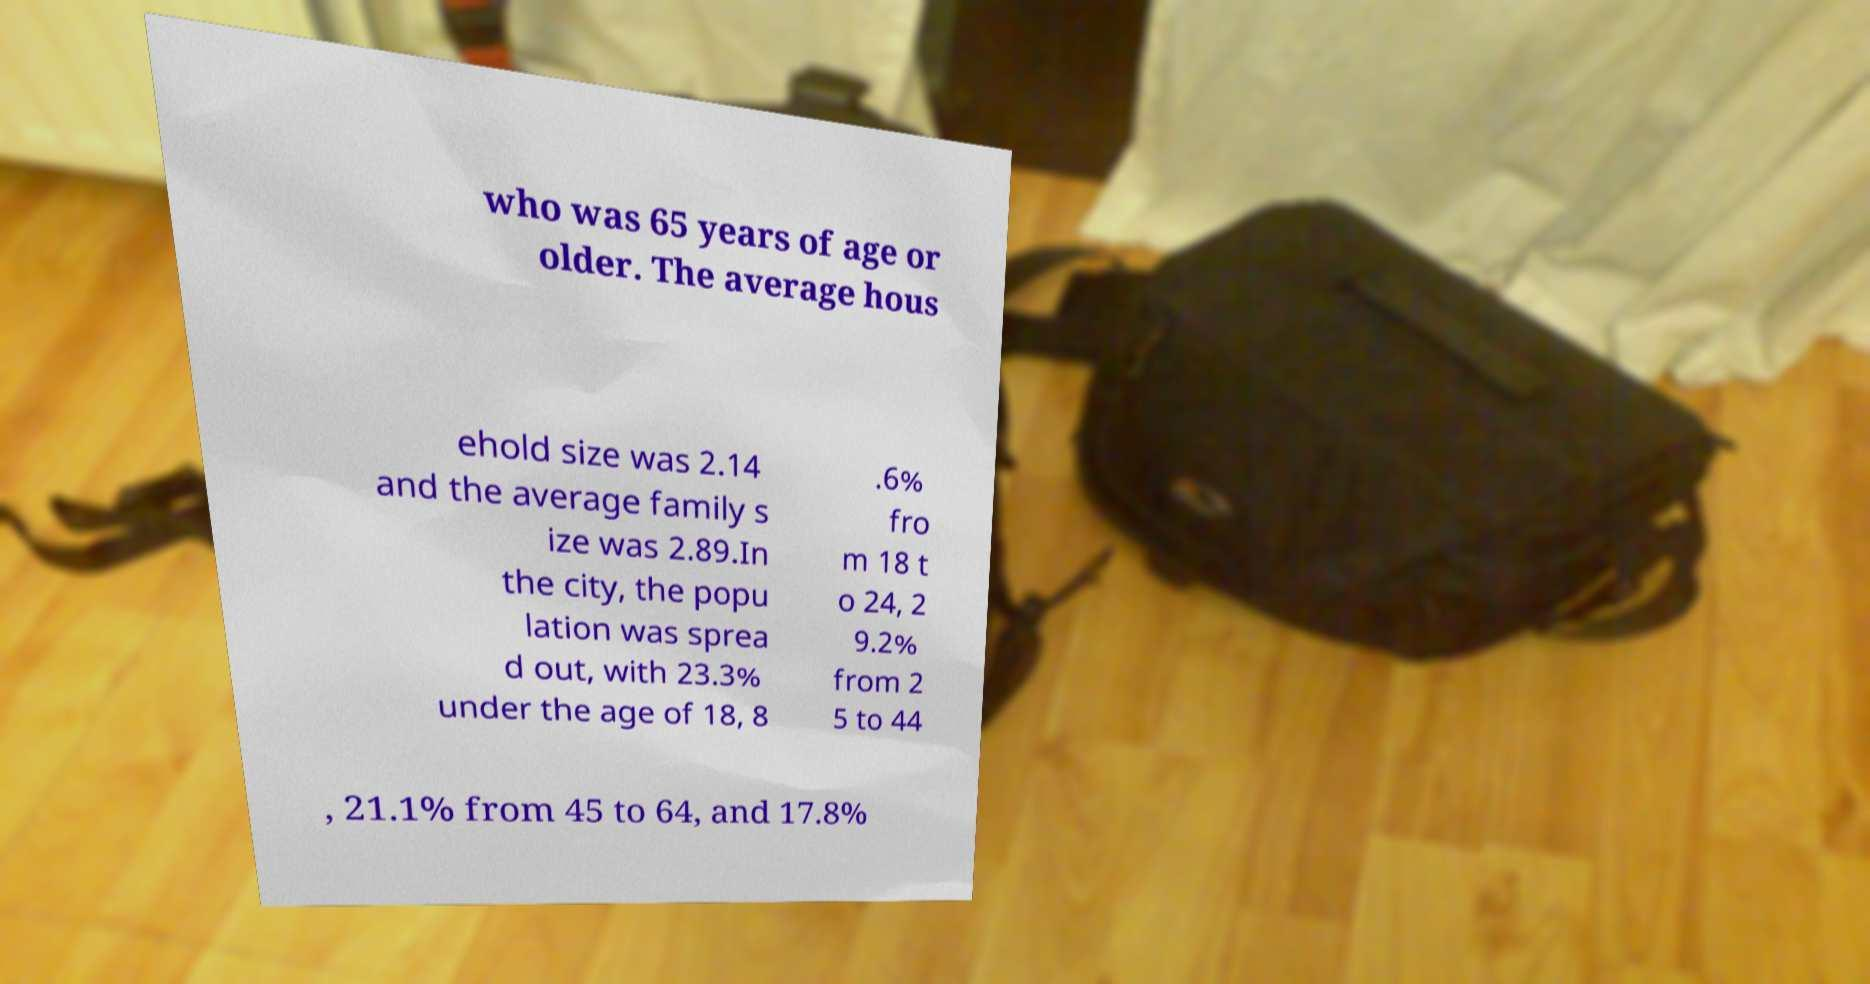There's text embedded in this image that I need extracted. Can you transcribe it verbatim? who was 65 years of age or older. The average hous ehold size was 2.14 and the average family s ize was 2.89.In the city, the popu lation was sprea d out, with 23.3% under the age of 18, 8 .6% fro m 18 t o 24, 2 9.2% from 2 5 to 44 , 21.1% from 45 to 64, and 17.8% 